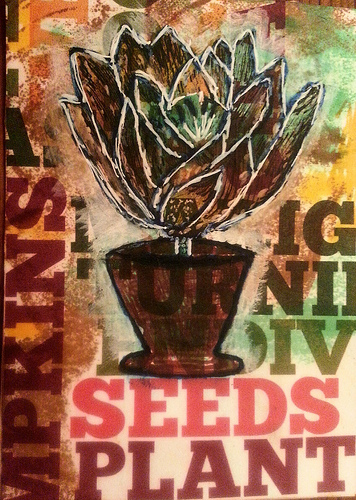<image>
Is there a seeds behind the plant? No. The seeds is not behind the plant. From this viewpoint, the seeds appears to be positioned elsewhere in the scene. 